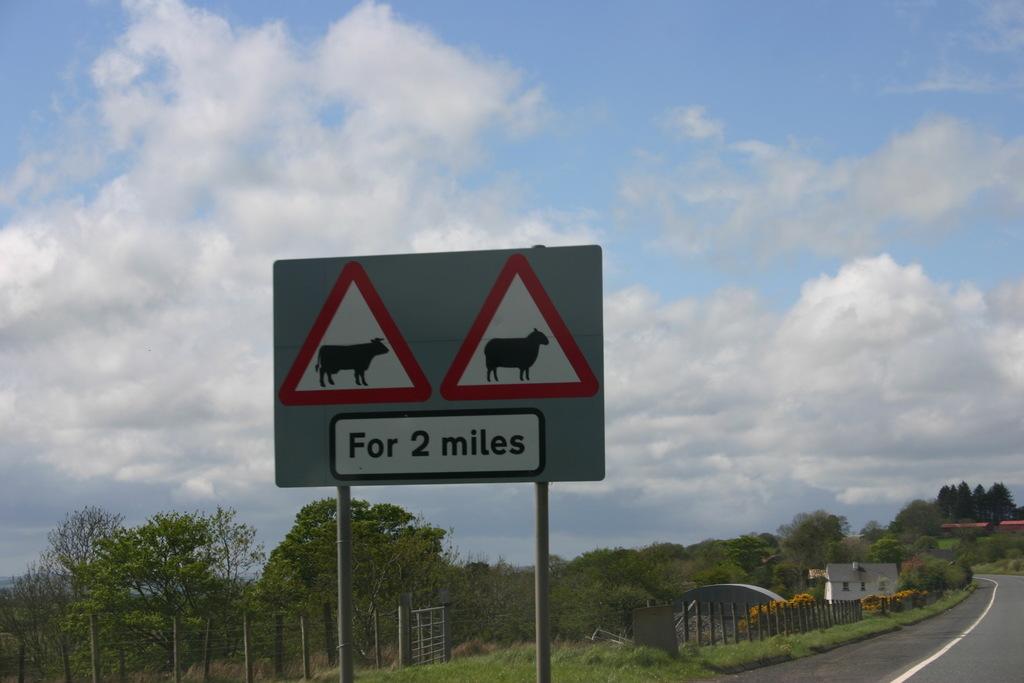How many miles?
Provide a short and direct response. 2. 